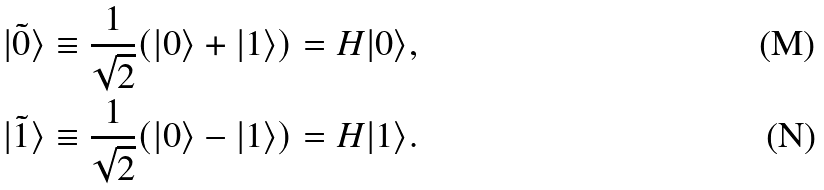Convert formula to latex. <formula><loc_0><loc_0><loc_500><loc_500>| \tilde { 0 } \rangle & \equiv \frac { 1 } { \sqrt { 2 } } ( | 0 \rangle + | 1 \rangle ) = H | 0 \rangle , \\ | \tilde { 1 } \rangle & \equiv \frac { 1 } { \sqrt { 2 } } ( | 0 \rangle - | 1 \rangle ) = H | 1 \rangle .</formula> 